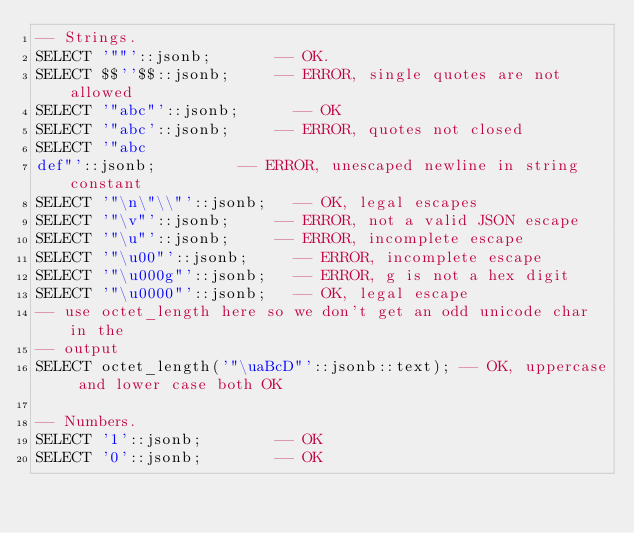Convert code to text. <code><loc_0><loc_0><loc_500><loc_500><_SQL_>-- Strings.
SELECT '""'::jsonb;				-- OK.
SELECT $$''$$::jsonb;			-- ERROR, single quotes are not allowed
SELECT '"abc"'::jsonb;			-- OK
SELECT '"abc'::jsonb;			-- ERROR, quotes not closed
SELECT '"abc
def"'::jsonb;					-- ERROR, unescaped newline in string constant
SELECT '"\n\"\\"'::jsonb;		-- OK, legal escapes
SELECT '"\v"'::jsonb;			-- ERROR, not a valid JSON escape
SELECT '"\u"'::jsonb;			-- ERROR, incomplete escape
SELECT '"\u00"'::jsonb;			-- ERROR, incomplete escape
SELECT '"\u000g"'::jsonb;		-- ERROR, g is not a hex digit
SELECT '"\u0000"'::jsonb;		-- OK, legal escape
-- use octet_length here so we don't get an odd unicode char in the
-- output
SELECT octet_length('"\uaBcD"'::jsonb::text); -- OK, uppercase and lower case both OK

-- Numbers.
SELECT '1'::jsonb;				-- OK
SELECT '0'::jsonb;				-- OK</code> 